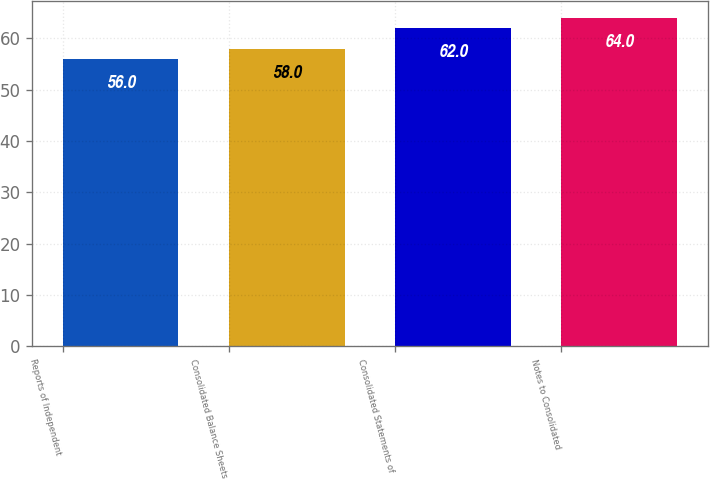Convert chart. <chart><loc_0><loc_0><loc_500><loc_500><bar_chart><fcel>Reports of Independent<fcel>Consolidated Balance Sheets<fcel>Consolidated Statements of<fcel>Notes to Consolidated<nl><fcel>56<fcel>58<fcel>62<fcel>64<nl></chart> 